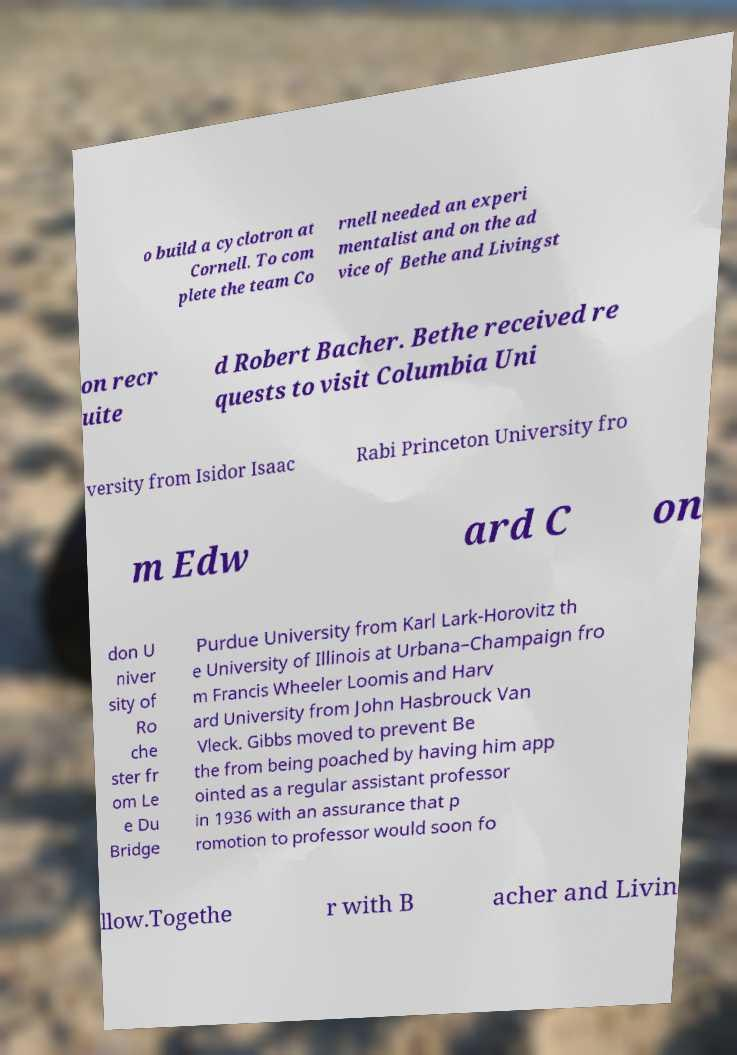What messages or text are displayed in this image? I need them in a readable, typed format. o build a cyclotron at Cornell. To com plete the team Co rnell needed an experi mentalist and on the ad vice of Bethe and Livingst on recr uite d Robert Bacher. Bethe received re quests to visit Columbia Uni versity from Isidor Isaac Rabi Princeton University fro m Edw ard C on don U niver sity of Ro che ster fr om Le e Du Bridge Purdue University from Karl Lark-Horovitz th e University of Illinois at Urbana–Champaign fro m Francis Wheeler Loomis and Harv ard University from John Hasbrouck Van Vleck. Gibbs moved to prevent Be the from being poached by having him app ointed as a regular assistant professor in 1936 with an assurance that p romotion to professor would soon fo llow.Togethe r with B acher and Livin 